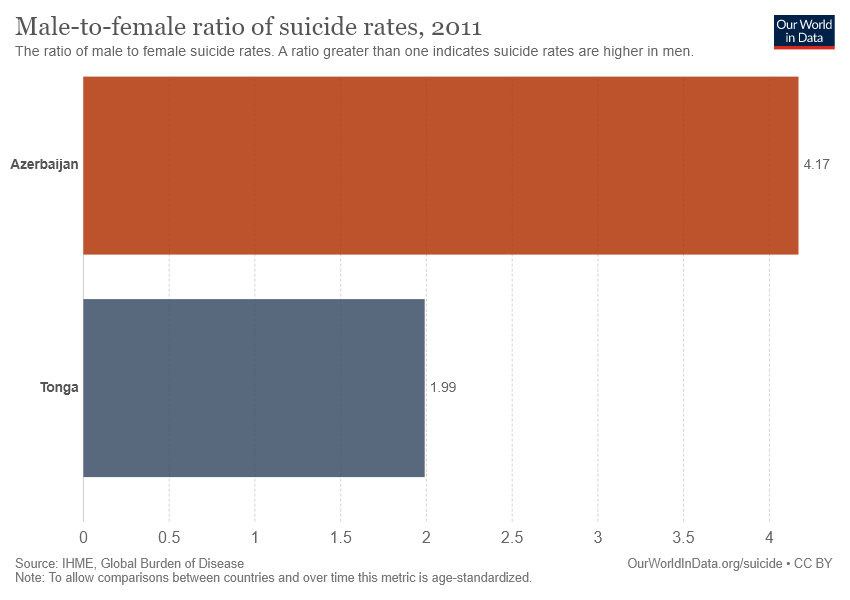Outline some significant characteristics in this image. According to the data, Azerbaijan has a higher male-to-female ratio of suicide rates compared to the other country/region. The average and total male-to-female ratio of suicide rates in these two countries are 3.08 and 6.16, respectively. 